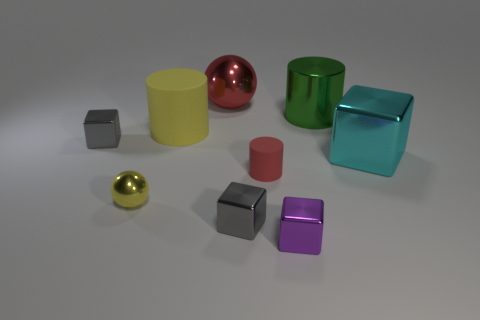There is a rubber cylinder that is the same size as the purple cube; what is its color?
Your answer should be compact. Red. Do the cyan object and the purple cube have the same size?
Ensure brevity in your answer.  No. There is a thing that is the same color as the large rubber cylinder; what is its shape?
Provide a succinct answer. Sphere. There is a green object; is it the same size as the gray thing that is to the left of the large yellow thing?
Provide a short and direct response. No. What is the color of the big metallic object that is both to the left of the large cyan object and in front of the big red metal sphere?
Your answer should be compact. Green. Are there more big red objects to the right of the red sphere than big shiny blocks on the left side of the tiny yellow shiny ball?
Provide a short and direct response. No. What is the size of the yellow object that is made of the same material as the tiny red cylinder?
Offer a terse response. Large. There is a block to the right of the purple metallic block; what number of large matte cylinders are in front of it?
Provide a short and direct response. 0. Is there a yellow matte object of the same shape as the yellow metallic thing?
Provide a short and direct response. No. The cube left of the small gray object in front of the tiny red cylinder is what color?
Keep it short and to the point. Gray. 